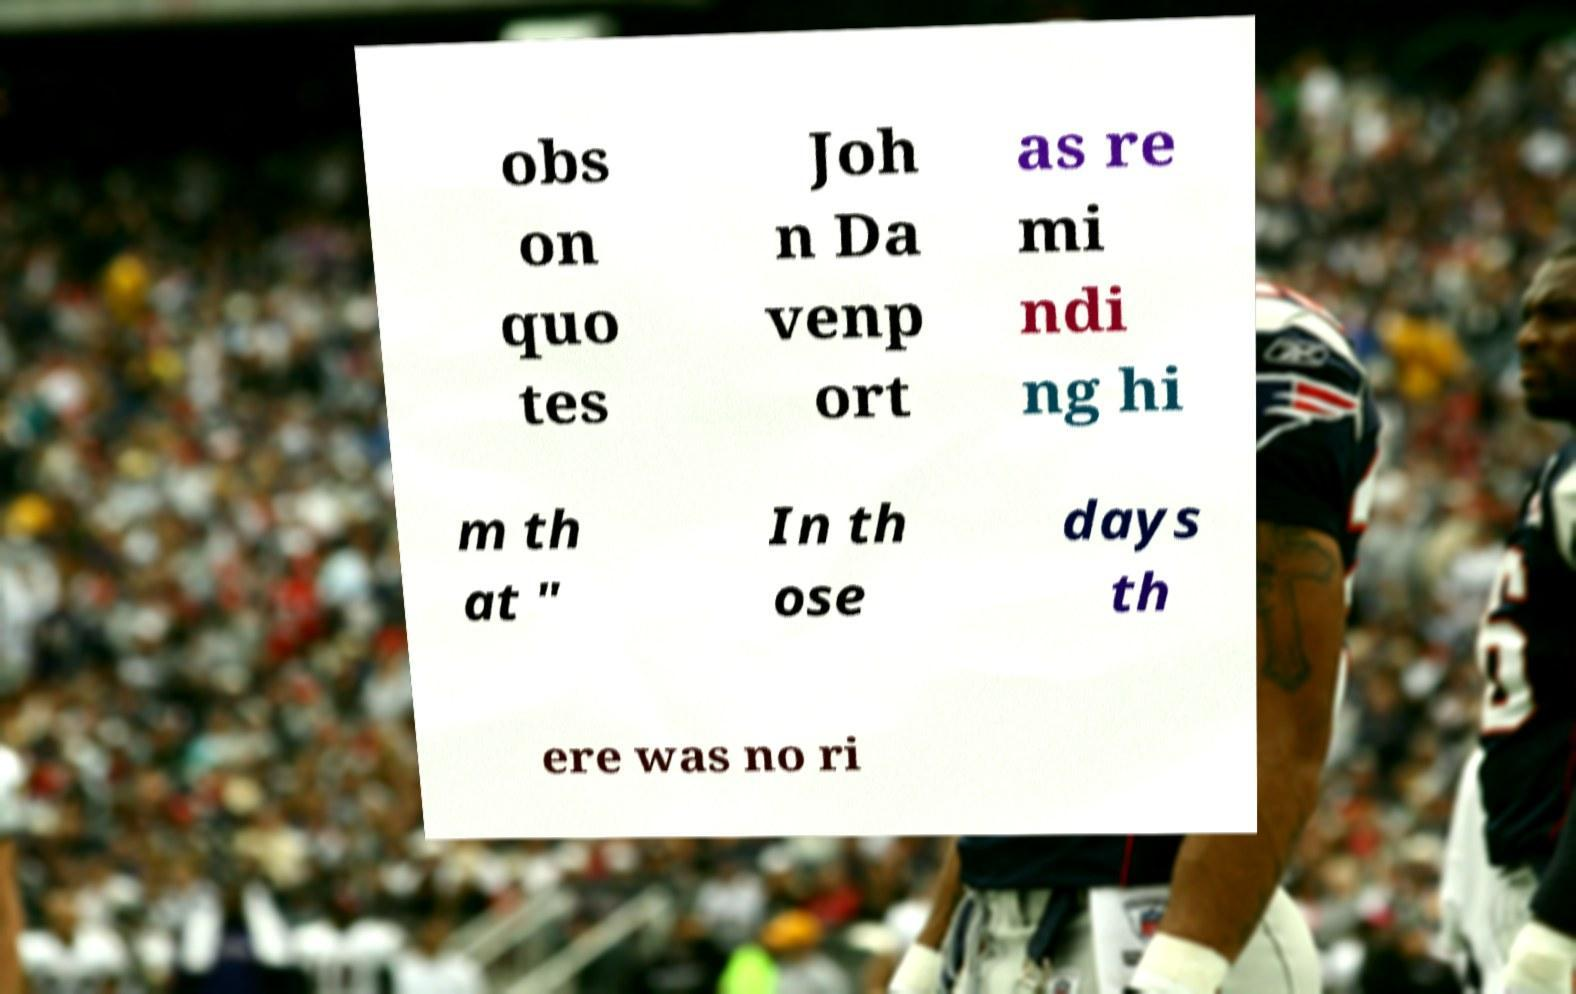Can you accurately transcribe the text from the provided image for me? obs on quo tes Joh n Da venp ort as re mi ndi ng hi m th at " In th ose days th ere was no ri 